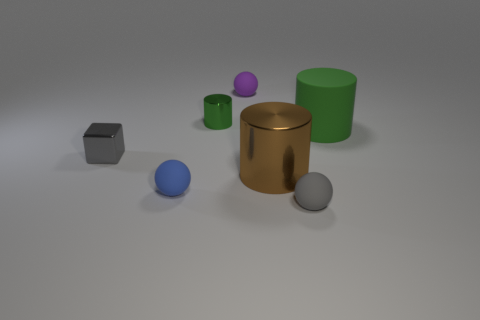Add 1 small red metallic cubes. How many objects exist? 8 Subtract all cylinders. How many objects are left? 4 Add 5 small red matte blocks. How many small red matte blocks exist? 5 Subtract 0 blue cubes. How many objects are left? 7 Subtract all brown matte spheres. Subtract all green metallic things. How many objects are left? 6 Add 7 brown cylinders. How many brown cylinders are left? 8 